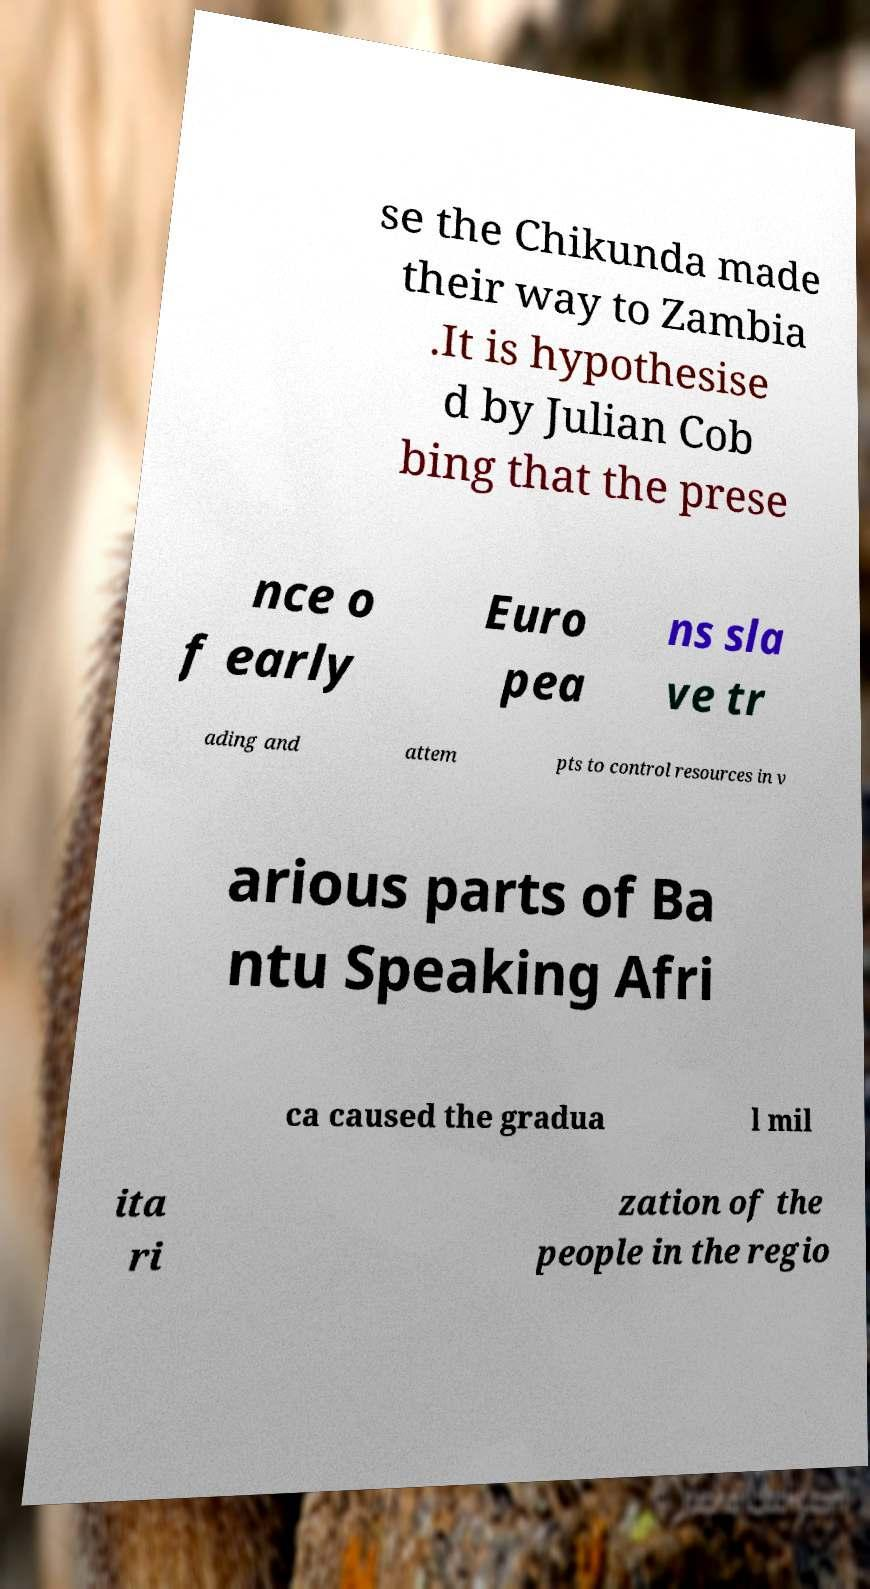Can you read and provide the text displayed in the image?This photo seems to have some interesting text. Can you extract and type it out for me? se the Chikunda made their way to Zambia .It is hypothesise d by Julian Cob bing that the prese nce o f early Euro pea ns sla ve tr ading and attem pts to control resources in v arious parts of Ba ntu Speaking Afri ca caused the gradua l mil ita ri zation of the people in the regio 